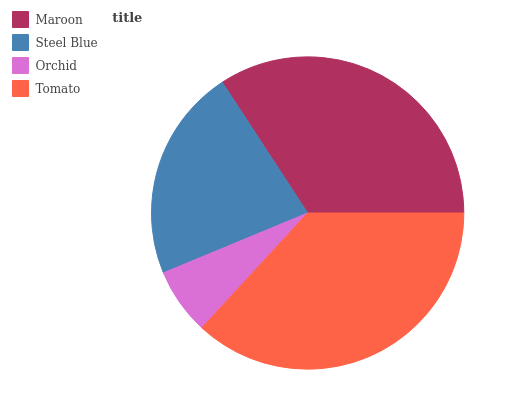Is Orchid the minimum?
Answer yes or no. Yes. Is Tomato the maximum?
Answer yes or no. Yes. Is Steel Blue the minimum?
Answer yes or no. No. Is Steel Blue the maximum?
Answer yes or no. No. Is Maroon greater than Steel Blue?
Answer yes or no. Yes. Is Steel Blue less than Maroon?
Answer yes or no. Yes. Is Steel Blue greater than Maroon?
Answer yes or no. No. Is Maroon less than Steel Blue?
Answer yes or no. No. Is Maroon the high median?
Answer yes or no. Yes. Is Steel Blue the low median?
Answer yes or no. Yes. Is Steel Blue the high median?
Answer yes or no. No. Is Orchid the low median?
Answer yes or no. No. 